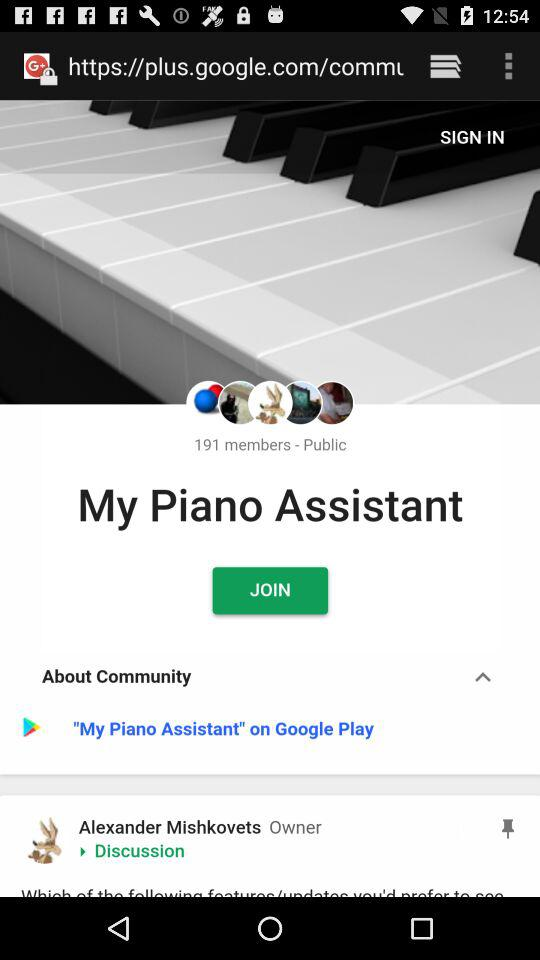How many members have joined "My Piano Assistant"? There are 191 members who joined "My Piano Assistant". 